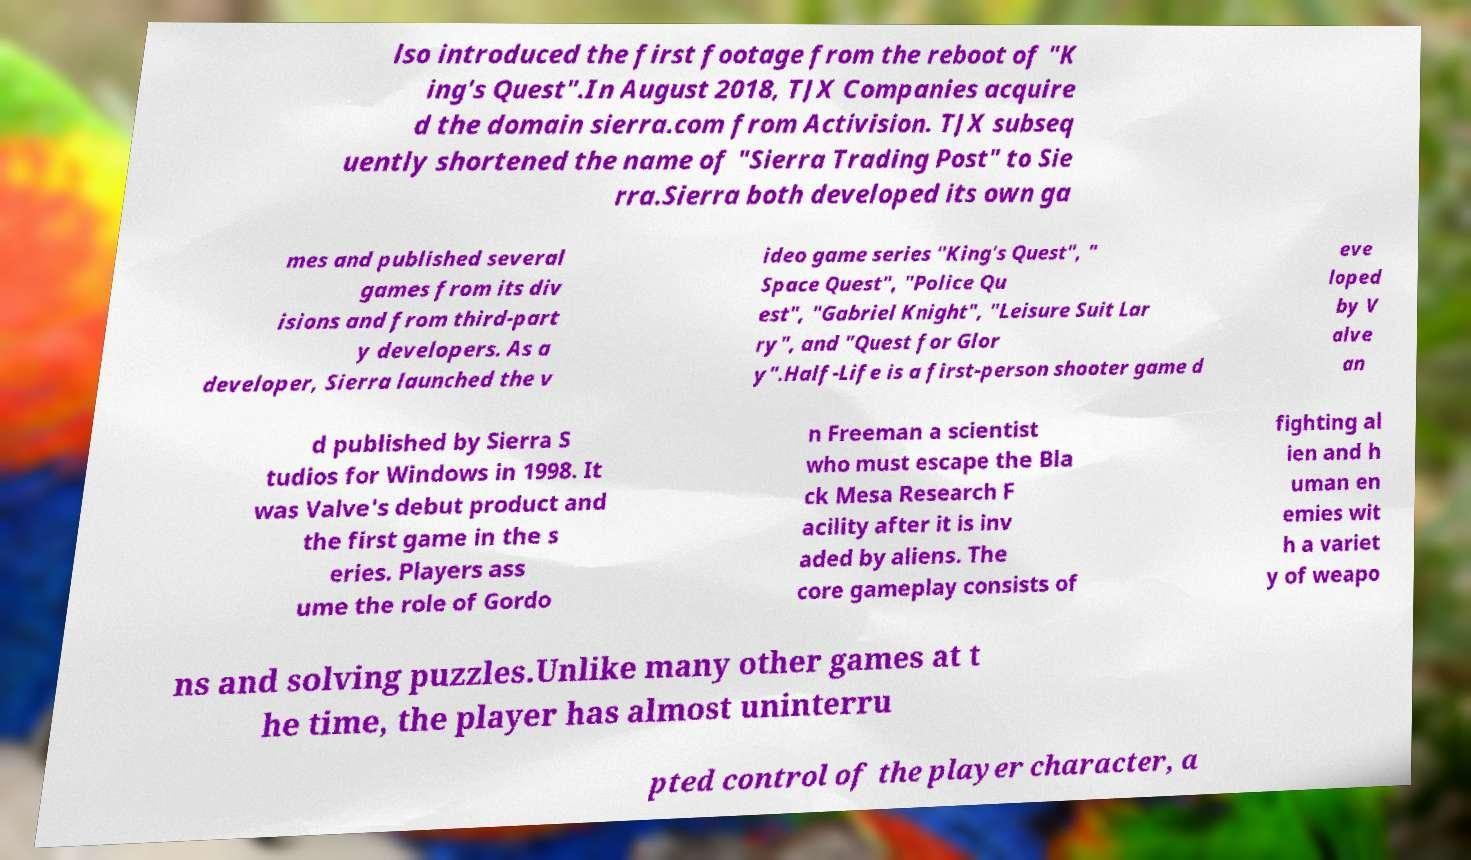Could you assist in decoding the text presented in this image and type it out clearly? lso introduced the first footage from the reboot of "K ing's Quest".In August 2018, TJX Companies acquire d the domain sierra.com from Activision. TJX subseq uently shortened the name of "Sierra Trading Post" to Sie rra.Sierra both developed its own ga mes and published several games from its div isions and from third-part y developers. As a developer, Sierra launched the v ideo game series "King's Quest", " Space Quest", "Police Qu est", "Gabriel Knight", "Leisure Suit Lar ry", and "Quest for Glor y".Half-Life is a first-person shooter game d eve loped by V alve an d published by Sierra S tudios for Windows in 1998. It was Valve's debut product and the first game in the s eries. Players ass ume the role of Gordo n Freeman a scientist who must escape the Bla ck Mesa Research F acility after it is inv aded by aliens. The core gameplay consists of fighting al ien and h uman en emies wit h a variet y of weapo ns and solving puzzles.Unlike many other games at t he time, the player has almost uninterru pted control of the player character, a 